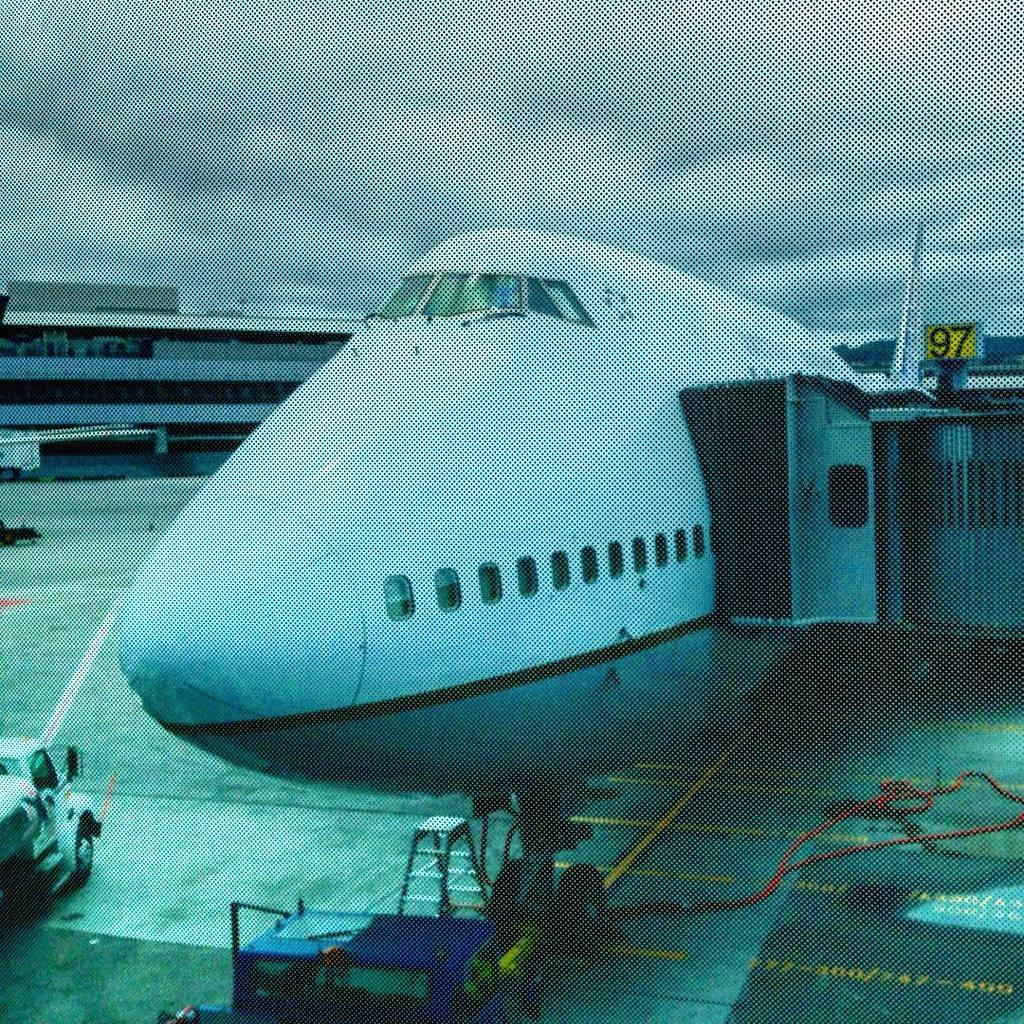<image>
Give a short and clear explanation of the subsequent image. A plane is beside a yellow number ninety seven sign. 